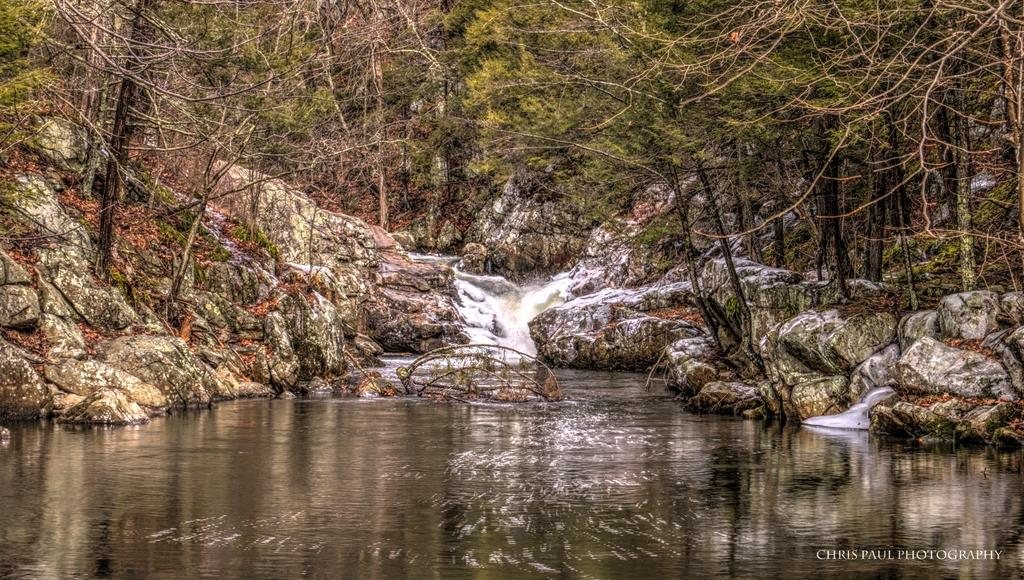What is the primary element visible in the image? There is water in the image. What other natural elements can be seen in the image? There are rocks and trees in the image. Where is the text or image located in the image? It is in the right bottom corner of the image. What type of suit can be seen hanging on the tree in the image? There is no suit present in the image; it features water, rocks, trees, and text or an image in the right bottom corner. 